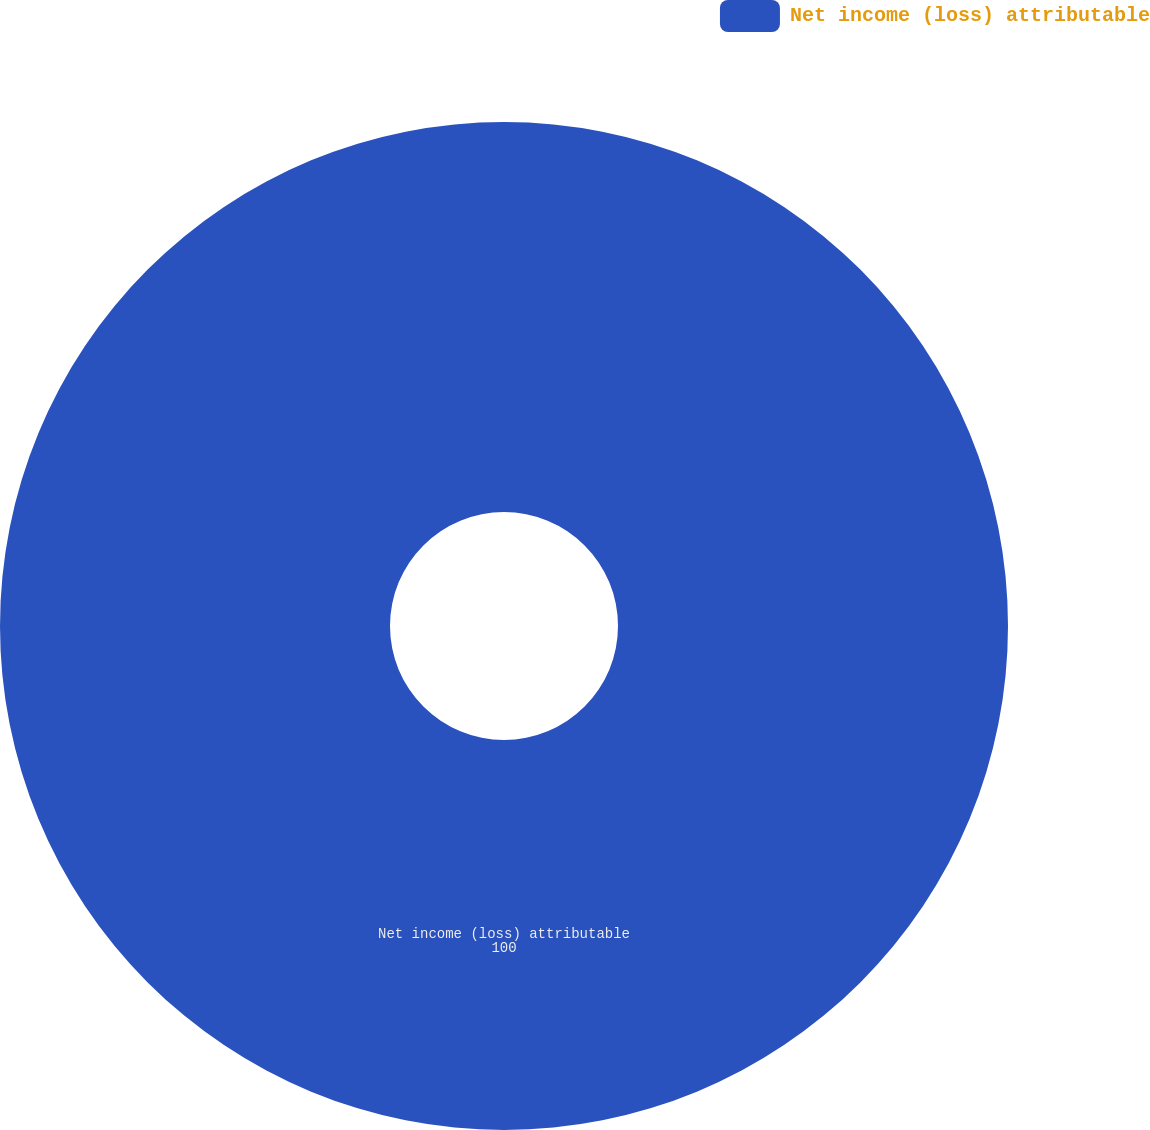Convert chart. <chart><loc_0><loc_0><loc_500><loc_500><pie_chart><fcel>Net income (loss) attributable<nl><fcel>100.0%<nl></chart> 